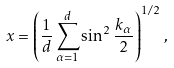<formula> <loc_0><loc_0><loc_500><loc_500>x = \left ( \frac { 1 } { d } \sum _ { \alpha = 1 } ^ { d } \sin ^ { 2 } \frac { k _ { \alpha } } { 2 } \right ) ^ { 1 / 2 } \, ,</formula> 